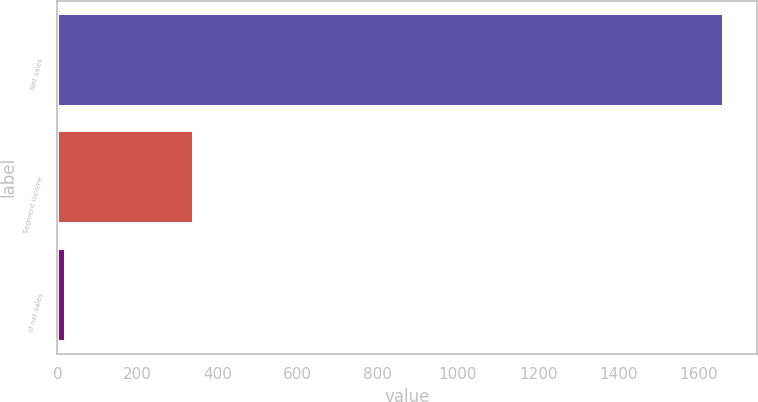Convert chart. <chart><loc_0><loc_0><loc_500><loc_500><bar_chart><fcel>Net sales<fcel>Segment income<fcel>of net sales<nl><fcel>1663.4<fcel>342<fcel>20.6<nl></chart> 